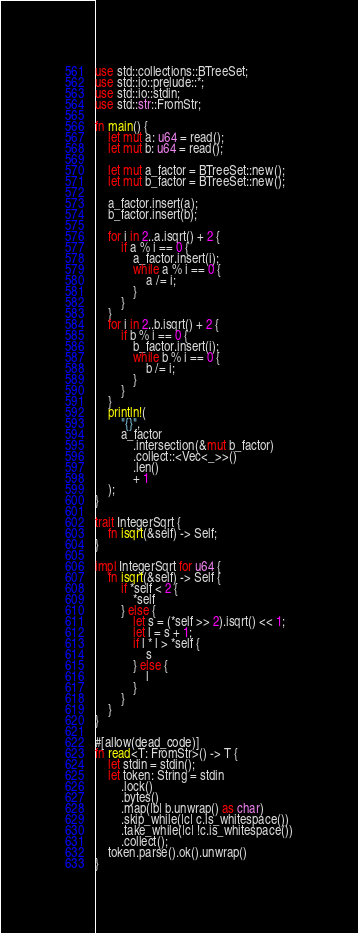Convert code to text. <code><loc_0><loc_0><loc_500><loc_500><_Rust_>use std::collections::BTreeSet;
use std::io::prelude::*;
use std::io::stdin;
use std::str::FromStr;

fn main() {
    let mut a: u64 = read();
    let mut b: u64 = read();

    let mut a_factor = BTreeSet::new();
    let mut b_factor = BTreeSet::new();

    a_factor.insert(a);
    b_factor.insert(b);

    for i in 2..a.isqrt() + 2 {
        if a % i == 0 {
            a_factor.insert(i);
            while a % i == 0 {
                a /= i;
            }
        }
    }
    for i in 2..b.isqrt() + 2 {
        if b % i == 0 {
            b_factor.insert(i);
            while b % i == 0 {
                b /= i;
            }
        }
    }
    println!(
        "{}",
        a_factor
            .intersection(&mut b_factor)
            .collect::<Vec<_>>()
            .len()
            + 1
    );
}

trait IntegerSqrt {
    fn isqrt(&self) -> Self;
}

impl IntegerSqrt for u64 {
    fn isqrt(&self) -> Self {
        if *self < 2 {
            *self
        } else {
            let s = (*self >> 2).isqrt() << 1;
            let l = s + 1;
            if l * l > *self {
                s
            } else {
                l
            }
        }
    }
}

#[allow(dead_code)]
fn read<T: FromStr>() -> T {
    let stdin = stdin();
    let token: String = stdin
        .lock()
        .bytes()
        .map(|b| b.unwrap() as char)
        .skip_while(|c| c.is_whitespace())
        .take_while(|c| !c.is_whitespace())
        .collect();
    token.parse().ok().unwrap()
}
</code> 